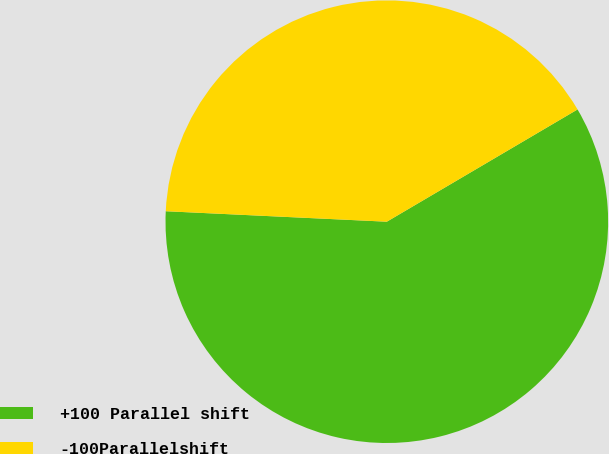<chart> <loc_0><loc_0><loc_500><loc_500><pie_chart><fcel>+100 Parallel shift<fcel>-100Parallelshift<nl><fcel>59.22%<fcel>40.78%<nl></chart> 